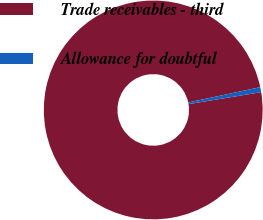Convert chart to OTSL. <chart><loc_0><loc_0><loc_500><loc_500><pie_chart><fcel>Trade receivables - third<fcel>Allowance for doubtful<nl><fcel>99.26%<fcel>0.74%<nl></chart> 